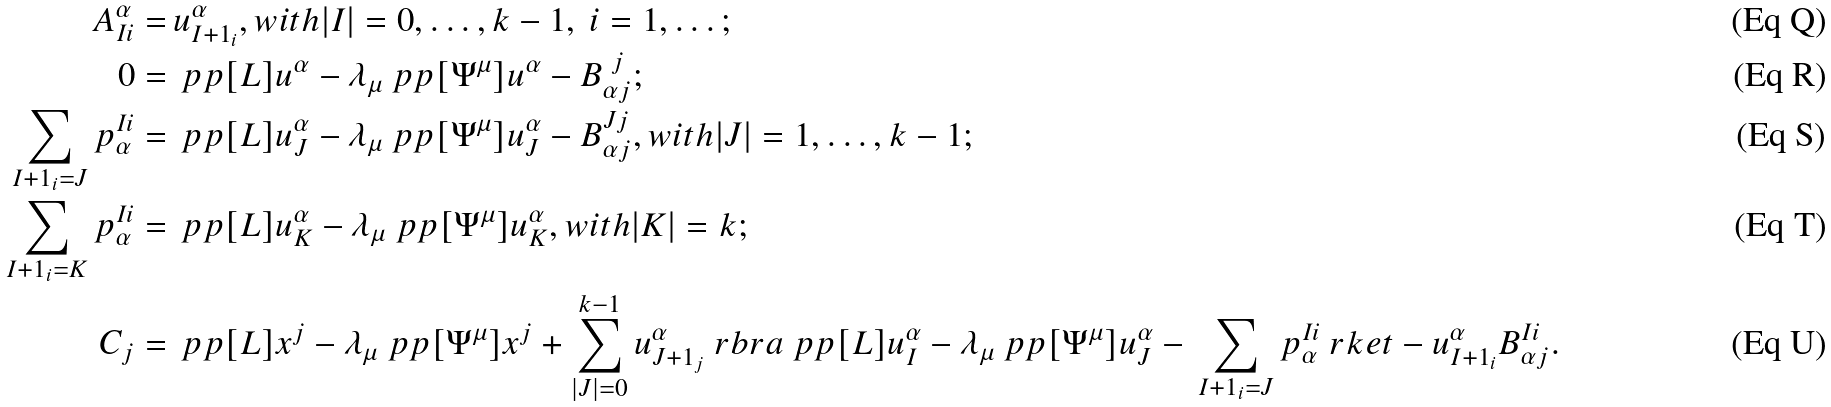Convert formula to latex. <formula><loc_0><loc_0><loc_500><loc_500>A ^ { \alpha } _ { I i } = \, & u ^ { \alpha } _ { I + 1 _ { i } } , w i t h | I | = 0 , \dots , k - 1 , \ i = 1 , \dots ; \\ 0 = \, & \ p p [ L ] { u ^ { \alpha } } - \lambda _ { \mu } \ p p [ \Psi ^ { \mu } ] { u ^ { \alpha } } - B ^ { \ j } _ { \alpha j } ; \\ \sum _ { I + 1 _ { i } = J } p ^ { I i } _ { \alpha } = \, & \ p p [ L ] { u ^ { \alpha } _ { J } } - \lambda _ { \mu } \ p p [ \Psi ^ { \mu } ] { u ^ { \alpha } _ { J } } - B ^ { J j } _ { \alpha j } , w i t h | J | = 1 , \dots , k - 1 ; \\ \sum _ { I + 1 _ { i } = K } p ^ { I i } _ { \alpha } = \, & \ p p [ L ] { u ^ { \alpha } _ { K } } - \lambda _ { \mu } \ p p [ \Psi ^ { \mu } ] { u ^ { \alpha } _ { K } } , w i t h | K | = k ; \\ C _ { j } = \, & \ p p [ L ] { x ^ { j } } - \lambda _ { \mu } \ p p [ \Psi ^ { \mu } ] { x ^ { j } } + \sum _ { | J | = 0 } ^ { k - 1 } u ^ { \alpha } _ { J + 1 _ { j } } \ r b r a \ p p [ L ] { u ^ { \alpha } _ { I } } - \lambda _ { \mu } \ p p [ \Psi ^ { \mu } ] { u ^ { \alpha } _ { J } } - \, \sum _ { I + 1 _ { i } = J } p ^ { I i } _ { \alpha } \ r k e t - u ^ { \alpha } _ { I + 1 _ { i } } B ^ { I i } _ { \alpha j } .</formula> 